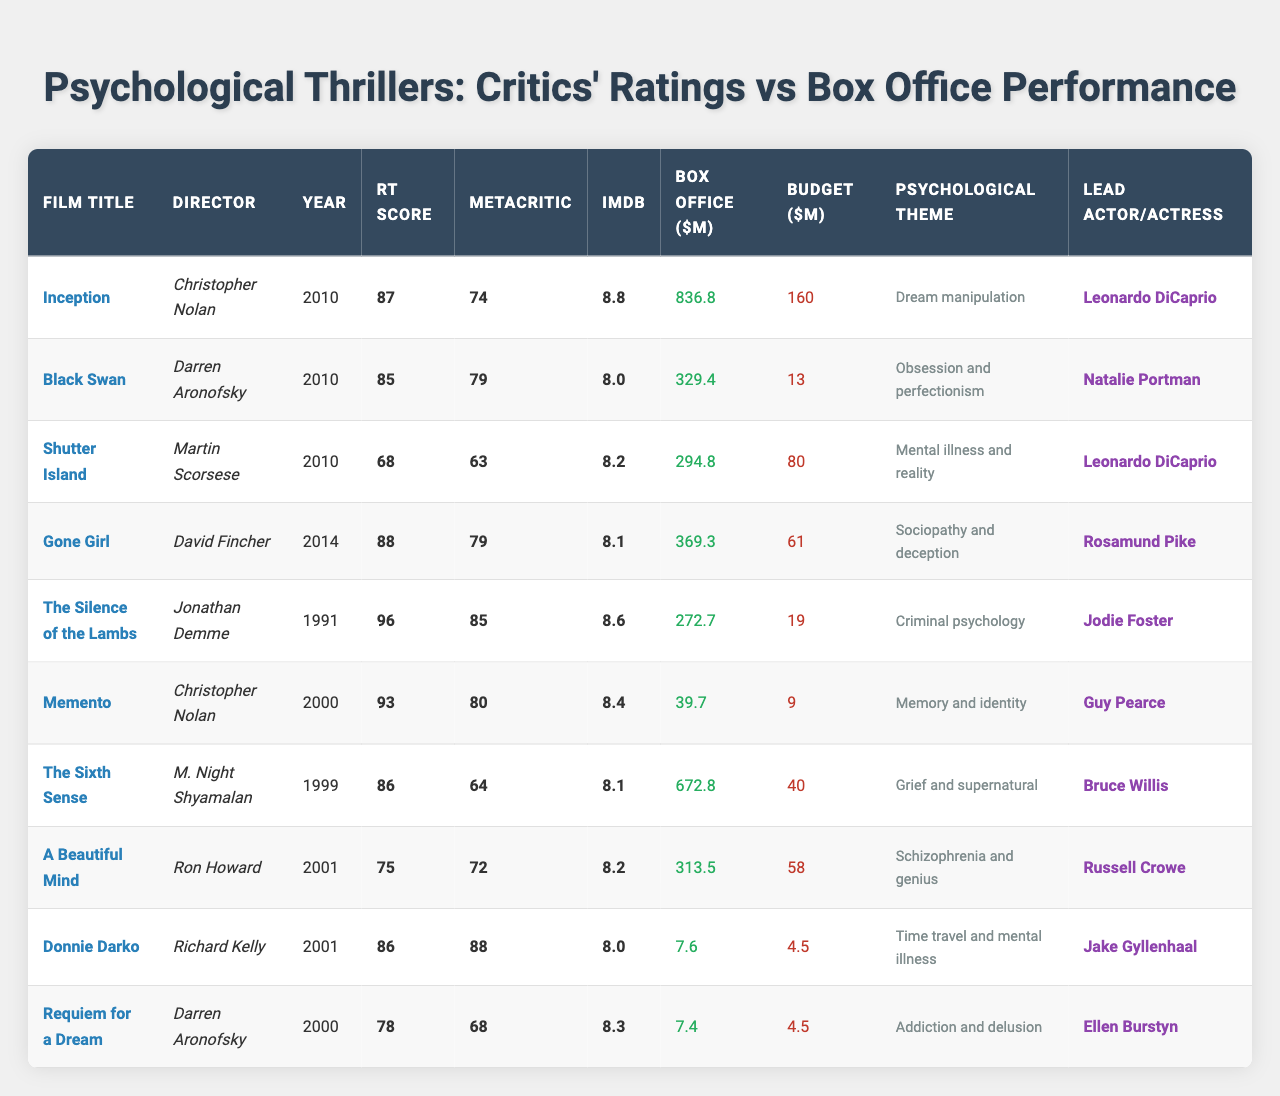Which film had the highest Rotten Tomatoes score? The Rotten Tomatoes scores are listed for each film. By scanning the column, "The Silence of the Lambs" has the highest score of 96.
Answer: The Silence of the Lambs What is the average IMDb rating of these films? The IMDb ratings are 8.8, 8.0, 8.2, 8.1, 8.6, 8.4, 8.1, 8.2, 8.0, and 8.3. Adding them gives 82.7, and dividing by 10 gives an average of 8.27.
Answer: 8.27 Did any film with a budget of less than 10 million earn over 300 million at the box office? Checking the films with a production budget less than 10 million: "Memento" ($9M) and "Requiem for a Dream" ($4.5M) earned only $39.7M and $7.4M respectively, so the answer is no.
Answer: No Which director has the most films listed in the table? By counting the entries, Christopher Nolan directed "Inception" and "Memento", while Darren Aronofsky directed "Black Swan" and "Requiem for a Dream". No director has more than two films listed. Therefore, the maximum is two films for these two directors.
Answer: 2 What is the difference in box office earnings between "Inception" and "Requiem for a Dream"? "Inception" earned $836.8 million, and "Requiem for a Dream" earned $7.4 million. The difference is $836.8M - $7.4M = $829.4M.
Answer: $829.4M Which film has both the highest IMDb rating and the highest box office earnings? "Inception" has the highest IMDb rating of 8.8 and box office earnings of $836.8M. To confirm, both highest values correspond to this film.
Answer: Inception Which film released in 2010 has the lowest Metacritic score? For 2010 releases, the films are "Inception," "Black Swan," and "Shutter Island." Their Metacritic scores are 74, 79, and 63 respectively; "Shutter Island" has the lowest score of 63.
Answer: Shutter Island Is the budget for "The Sixth Sense" less than its box office earnings? "The Sixth Sense" had a production budget of $40 million and earned $672.8 million at the box office, confirming that its earnings surpassed the budget.
Answer: Yes What is the sum of Rotten Tomatoes scores for films directed by Darren Aronofsky? The films directed by Darren Aronofsky are "Black Swan" (85) and "Requiem for a Dream" (78), giving a sum of 85 + 78 = 163.
Answer: 163 How many films in the table are focused on themes of "addiction and delusion"? The only film listed with that theme is "Requiem for a Dream," so there is only one film with that psychological theme.
Answer: 1 Which film had the highest box office profits relative to its production budget? To find this, calculate the box office earnings minus the production budget for each film. "Inception" shows the highest profit of $836.8M - $160M = $676.8M.
Answer: Inception 